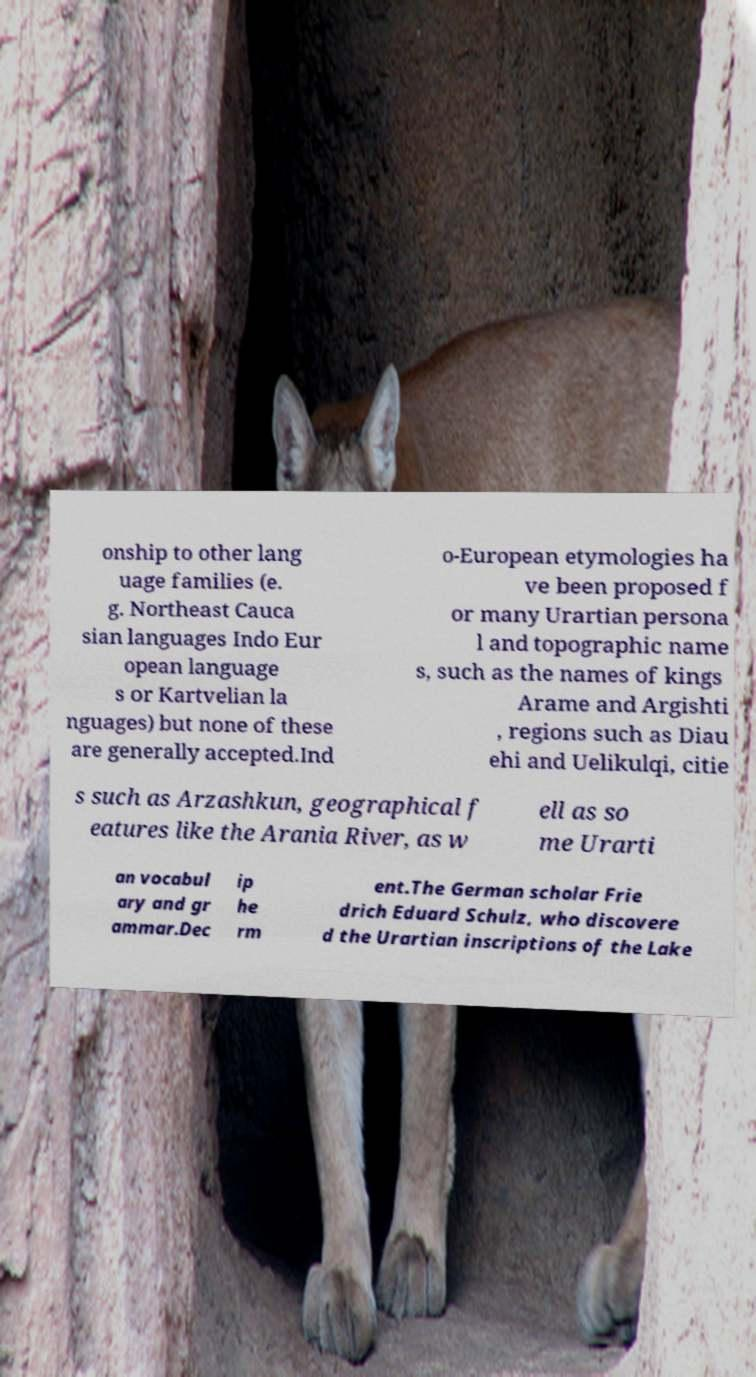Please identify and transcribe the text found in this image. onship to other lang uage families (e. g. Northeast Cauca sian languages Indo Eur opean language s or Kartvelian la nguages) but none of these are generally accepted.Ind o-European etymologies ha ve been proposed f or many Urartian persona l and topographic name s, such as the names of kings Arame and Argishti , regions such as Diau ehi and Uelikulqi, citie s such as Arzashkun, geographical f eatures like the Arania River, as w ell as so me Urarti an vocabul ary and gr ammar.Dec ip he rm ent.The German scholar Frie drich Eduard Schulz, who discovere d the Urartian inscriptions of the Lake 